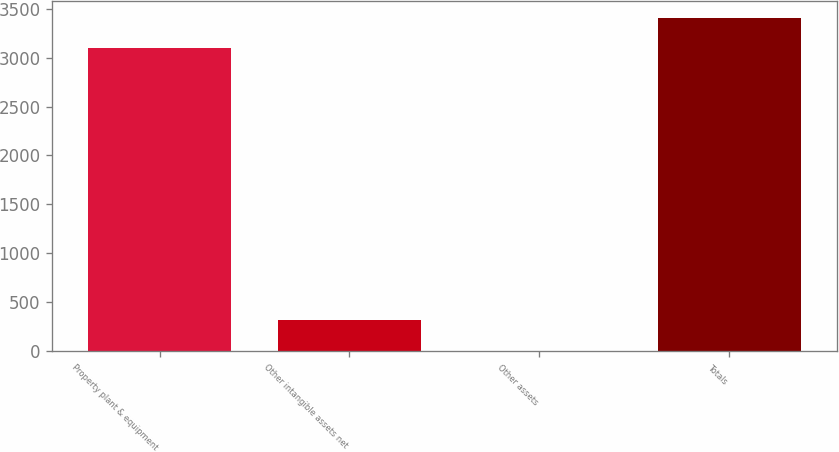Convert chart to OTSL. <chart><loc_0><loc_0><loc_500><loc_500><bar_chart><fcel>Property plant & equipment<fcel>Other intangible assets net<fcel>Other assets<fcel>Totals<nl><fcel>3095<fcel>311.8<fcel>2.56<fcel>3404.24<nl></chart> 